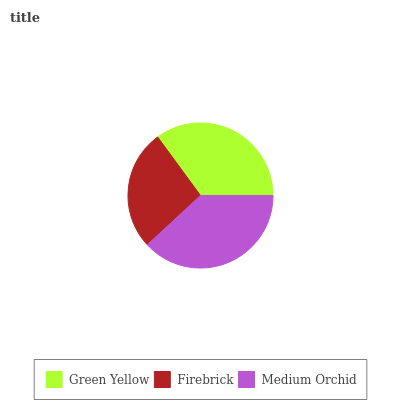Is Firebrick the minimum?
Answer yes or no. Yes. Is Medium Orchid the maximum?
Answer yes or no. Yes. Is Medium Orchid the minimum?
Answer yes or no. No. Is Firebrick the maximum?
Answer yes or no. No. Is Medium Orchid greater than Firebrick?
Answer yes or no. Yes. Is Firebrick less than Medium Orchid?
Answer yes or no. Yes. Is Firebrick greater than Medium Orchid?
Answer yes or no. No. Is Medium Orchid less than Firebrick?
Answer yes or no. No. Is Green Yellow the high median?
Answer yes or no. Yes. Is Green Yellow the low median?
Answer yes or no. Yes. Is Medium Orchid the high median?
Answer yes or no. No. Is Medium Orchid the low median?
Answer yes or no. No. 